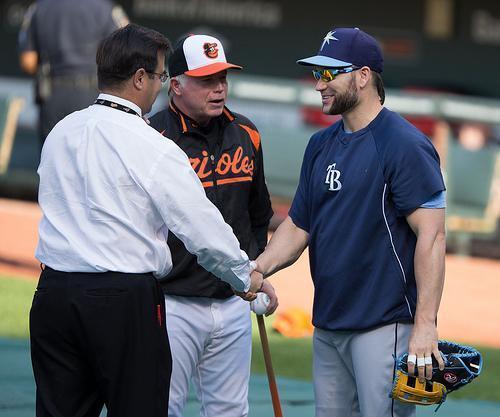How many people are wearing glasses?
Give a very brief answer. 2. 